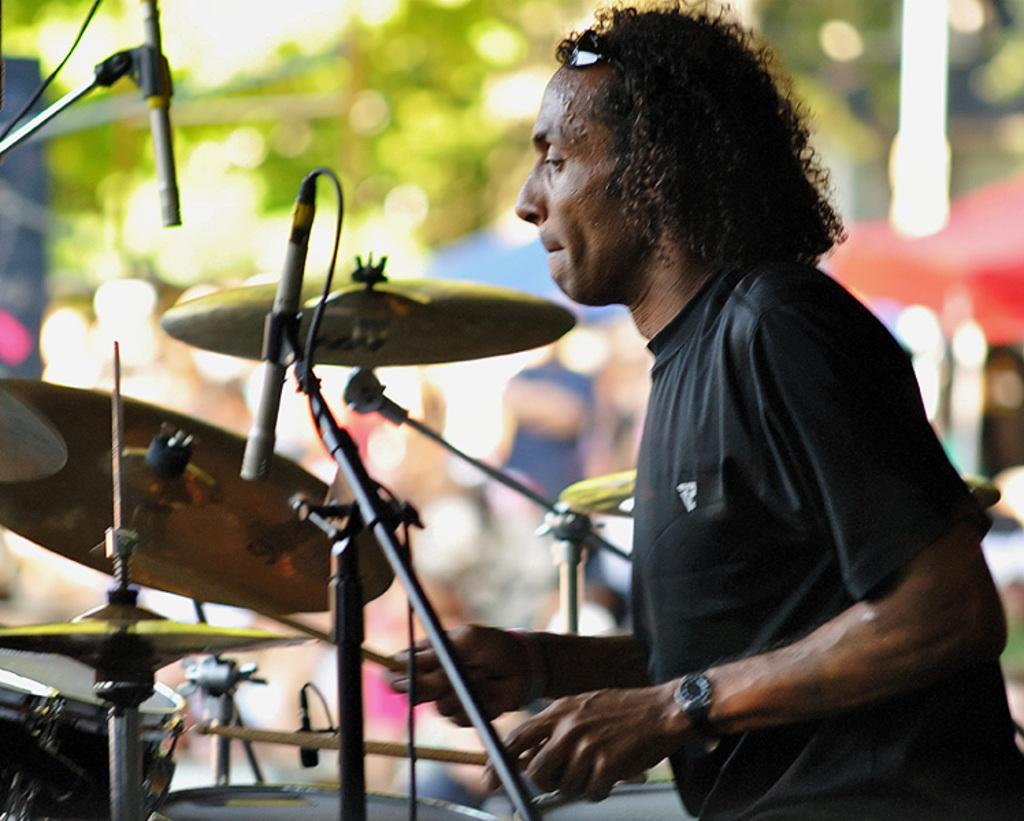How would you summarize this image in a sentence or two? In this image there is a man playing a musical instrument holding two sticks in his hand. 